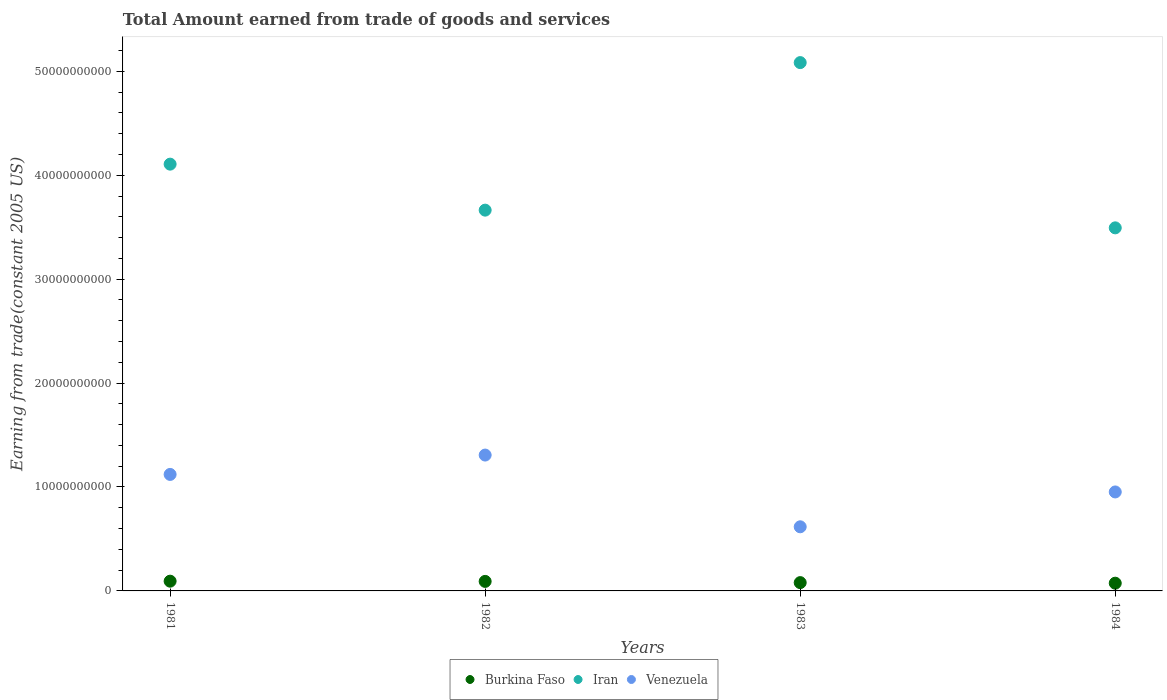Is the number of dotlines equal to the number of legend labels?
Offer a very short reply. Yes. What is the total amount earned by trading goods and services in Iran in 1983?
Give a very brief answer. 5.08e+1. Across all years, what is the maximum total amount earned by trading goods and services in Burkina Faso?
Offer a very short reply. 9.37e+08. Across all years, what is the minimum total amount earned by trading goods and services in Iran?
Provide a succinct answer. 3.49e+1. In which year was the total amount earned by trading goods and services in Iran maximum?
Make the answer very short. 1983. In which year was the total amount earned by trading goods and services in Iran minimum?
Keep it short and to the point. 1984. What is the total total amount earned by trading goods and services in Burkina Faso in the graph?
Provide a succinct answer. 3.40e+09. What is the difference between the total amount earned by trading goods and services in Venezuela in 1981 and that in 1984?
Your response must be concise. 1.69e+09. What is the difference between the total amount earned by trading goods and services in Venezuela in 1981 and the total amount earned by trading goods and services in Burkina Faso in 1982?
Ensure brevity in your answer.  1.03e+1. What is the average total amount earned by trading goods and services in Burkina Faso per year?
Offer a very short reply. 8.49e+08. In the year 1982, what is the difference between the total amount earned by trading goods and services in Venezuela and total amount earned by trading goods and services in Iran?
Provide a succinct answer. -2.36e+1. In how many years, is the total amount earned by trading goods and services in Iran greater than 20000000000 US$?
Keep it short and to the point. 4. What is the ratio of the total amount earned by trading goods and services in Iran in 1981 to that in 1984?
Keep it short and to the point. 1.18. Is the total amount earned by trading goods and services in Burkina Faso in 1981 less than that in 1983?
Make the answer very short. No. Is the difference between the total amount earned by trading goods and services in Venezuela in 1981 and 1982 greater than the difference between the total amount earned by trading goods and services in Iran in 1981 and 1982?
Ensure brevity in your answer.  No. What is the difference between the highest and the second highest total amount earned by trading goods and services in Burkina Faso?
Keep it short and to the point. 2.11e+07. What is the difference between the highest and the lowest total amount earned by trading goods and services in Venezuela?
Give a very brief answer. 6.90e+09. In how many years, is the total amount earned by trading goods and services in Iran greater than the average total amount earned by trading goods and services in Iran taken over all years?
Keep it short and to the point. 2. Is the sum of the total amount earned by trading goods and services in Burkina Faso in 1982 and 1984 greater than the maximum total amount earned by trading goods and services in Iran across all years?
Provide a succinct answer. No. Does the total amount earned by trading goods and services in Burkina Faso monotonically increase over the years?
Give a very brief answer. No. How many years are there in the graph?
Provide a succinct answer. 4. Are the values on the major ticks of Y-axis written in scientific E-notation?
Offer a terse response. No. Does the graph contain any zero values?
Provide a succinct answer. No. Where does the legend appear in the graph?
Provide a short and direct response. Bottom center. How many legend labels are there?
Your response must be concise. 3. How are the legend labels stacked?
Give a very brief answer. Horizontal. What is the title of the graph?
Provide a succinct answer. Total Amount earned from trade of goods and services. Does "India" appear as one of the legend labels in the graph?
Keep it short and to the point. No. What is the label or title of the Y-axis?
Your answer should be very brief. Earning from trade(constant 2005 US). What is the Earning from trade(constant 2005 US) in Burkina Faso in 1981?
Your answer should be compact. 9.37e+08. What is the Earning from trade(constant 2005 US) in Iran in 1981?
Provide a succinct answer. 4.11e+1. What is the Earning from trade(constant 2005 US) of Venezuela in 1981?
Keep it short and to the point. 1.12e+1. What is the Earning from trade(constant 2005 US) in Burkina Faso in 1982?
Keep it short and to the point. 9.16e+08. What is the Earning from trade(constant 2005 US) in Iran in 1982?
Provide a short and direct response. 3.66e+1. What is the Earning from trade(constant 2005 US) of Venezuela in 1982?
Provide a short and direct response. 1.31e+1. What is the Earning from trade(constant 2005 US) of Burkina Faso in 1983?
Your response must be concise. 7.99e+08. What is the Earning from trade(constant 2005 US) in Iran in 1983?
Provide a succinct answer. 5.08e+1. What is the Earning from trade(constant 2005 US) in Venezuela in 1983?
Offer a terse response. 6.17e+09. What is the Earning from trade(constant 2005 US) of Burkina Faso in 1984?
Your answer should be very brief. 7.44e+08. What is the Earning from trade(constant 2005 US) of Iran in 1984?
Ensure brevity in your answer.  3.49e+1. What is the Earning from trade(constant 2005 US) of Venezuela in 1984?
Offer a very short reply. 9.52e+09. Across all years, what is the maximum Earning from trade(constant 2005 US) in Burkina Faso?
Keep it short and to the point. 9.37e+08. Across all years, what is the maximum Earning from trade(constant 2005 US) of Iran?
Your answer should be very brief. 5.08e+1. Across all years, what is the maximum Earning from trade(constant 2005 US) of Venezuela?
Keep it short and to the point. 1.31e+1. Across all years, what is the minimum Earning from trade(constant 2005 US) in Burkina Faso?
Your answer should be compact. 7.44e+08. Across all years, what is the minimum Earning from trade(constant 2005 US) of Iran?
Offer a very short reply. 3.49e+1. Across all years, what is the minimum Earning from trade(constant 2005 US) in Venezuela?
Your answer should be very brief. 6.17e+09. What is the total Earning from trade(constant 2005 US) in Burkina Faso in the graph?
Your answer should be compact. 3.40e+09. What is the total Earning from trade(constant 2005 US) in Iran in the graph?
Your answer should be compact. 1.63e+11. What is the total Earning from trade(constant 2005 US) in Venezuela in the graph?
Keep it short and to the point. 4.00e+1. What is the difference between the Earning from trade(constant 2005 US) in Burkina Faso in 1981 and that in 1982?
Offer a very short reply. 2.11e+07. What is the difference between the Earning from trade(constant 2005 US) of Iran in 1981 and that in 1982?
Your answer should be compact. 4.43e+09. What is the difference between the Earning from trade(constant 2005 US) of Venezuela in 1981 and that in 1982?
Your answer should be compact. -1.86e+09. What is the difference between the Earning from trade(constant 2005 US) of Burkina Faso in 1981 and that in 1983?
Give a very brief answer. 1.39e+08. What is the difference between the Earning from trade(constant 2005 US) of Iran in 1981 and that in 1983?
Offer a very short reply. -9.77e+09. What is the difference between the Earning from trade(constant 2005 US) in Venezuela in 1981 and that in 1983?
Provide a succinct answer. 5.04e+09. What is the difference between the Earning from trade(constant 2005 US) in Burkina Faso in 1981 and that in 1984?
Offer a terse response. 1.93e+08. What is the difference between the Earning from trade(constant 2005 US) in Iran in 1981 and that in 1984?
Offer a very short reply. 6.13e+09. What is the difference between the Earning from trade(constant 2005 US) of Venezuela in 1981 and that in 1984?
Your response must be concise. 1.69e+09. What is the difference between the Earning from trade(constant 2005 US) in Burkina Faso in 1982 and that in 1983?
Keep it short and to the point. 1.17e+08. What is the difference between the Earning from trade(constant 2005 US) in Iran in 1982 and that in 1983?
Make the answer very short. -1.42e+1. What is the difference between the Earning from trade(constant 2005 US) in Venezuela in 1982 and that in 1983?
Offer a terse response. 6.90e+09. What is the difference between the Earning from trade(constant 2005 US) of Burkina Faso in 1982 and that in 1984?
Your answer should be compact. 1.72e+08. What is the difference between the Earning from trade(constant 2005 US) in Iran in 1982 and that in 1984?
Provide a short and direct response. 1.70e+09. What is the difference between the Earning from trade(constant 2005 US) in Venezuela in 1982 and that in 1984?
Your answer should be compact. 3.55e+09. What is the difference between the Earning from trade(constant 2005 US) in Burkina Faso in 1983 and that in 1984?
Keep it short and to the point. 5.48e+07. What is the difference between the Earning from trade(constant 2005 US) in Iran in 1983 and that in 1984?
Offer a terse response. 1.59e+1. What is the difference between the Earning from trade(constant 2005 US) in Venezuela in 1983 and that in 1984?
Provide a succinct answer. -3.35e+09. What is the difference between the Earning from trade(constant 2005 US) in Burkina Faso in 1981 and the Earning from trade(constant 2005 US) in Iran in 1982?
Provide a short and direct response. -3.57e+1. What is the difference between the Earning from trade(constant 2005 US) in Burkina Faso in 1981 and the Earning from trade(constant 2005 US) in Venezuela in 1982?
Make the answer very short. -1.21e+1. What is the difference between the Earning from trade(constant 2005 US) in Iran in 1981 and the Earning from trade(constant 2005 US) in Venezuela in 1982?
Your answer should be compact. 2.80e+1. What is the difference between the Earning from trade(constant 2005 US) of Burkina Faso in 1981 and the Earning from trade(constant 2005 US) of Iran in 1983?
Your response must be concise. -4.99e+1. What is the difference between the Earning from trade(constant 2005 US) of Burkina Faso in 1981 and the Earning from trade(constant 2005 US) of Venezuela in 1983?
Your response must be concise. -5.23e+09. What is the difference between the Earning from trade(constant 2005 US) in Iran in 1981 and the Earning from trade(constant 2005 US) in Venezuela in 1983?
Provide a succinct answer. 3.49e+1. What is the difference between the Earning from trade(constant 2005 US) of Burkina Faso in 1981 and the Earning from trade(constant 2005 US) of Iran in 1984?
Keep it short and to the point. -3.40e+1. What is the difference between the Earning from trade(constant 2005 US) in Burkina Faso in 1981 and the Earning from trade(constant 2005 US) in Venezuela in 1984?
Ensure brevity in your answer.  -8.59e+09. What is the difference between the Earning from trade(constant 2005 US) in Iran in 1981 and the Earning from trade(constant 2005 US) in Venezuela in 1984?
Offer a very short reply. 3.15e+1. What is the difference between the Earning from trade(constant 2005 US) in Burkina Faso in 1982 and the Earning from trade(constant 2005 US) in Iran in 1983?
Make the answer very short. -4.99e+1. What is the difference between the Earning from trade(constant 2005 US) of Burkina Faso in 1982 and the Earning from trade(constant 2005 US) of Venezuela in 1983?
Give a very brief answer. -5.25e+09. What is the difference between the Earning from trade(constant 2005 US) of Iran in 1982 and the Earning from trade(constant 2005 US) of Venezuela in 1983?
Keep it short and to the point. 3.05e+1. What is the difference between the Earning from trade(constant 2005 US) of Burkina Faso in 1982 and the Earning from trade(constant 2005 US) of Iran in 1984?
Give a very brief answer. -3.40e+1. What is the difference between the Earning from trade(constant 2005 US) of Burkina Faso in 1982 and the Earning from trade(constant 2005 US) of Venezuela in 1984?
Make the answer very short. -8.61e+09. What is the difference between the Earning from trade(constant 2005 US) in Iran in 1982 and the Earning from trade(constant 2005 US) in Venezuela in 1984?
Your response must be concise. 2.71e+1. What is the difference between the Earning from trade(constant 2005 US) in Burkina Faso in 1983 and the Earning from trade(constant 2005 US) in Iran in 1984?
Keep it short and to the point. -3.41e+1. What is the difference between the Earning from trade(constant 2005 US) of Burkina Faso in 1983 and the Earning from trade(constant 2005 US) of Venezuela in 1984?
Provide a short and direct response. -8.72e+09. What is the difference between the Earning from trade(constant 2005 US) in Iran in 1983 and the Earning from trade(constant 2005 US) in Venezuela in 1984?
Offer a terse response. 4.13e+1. What is the average Earning from trade(constant 2005 US) of Burkina Faso per year?
Provide a succinct answer. 8.49e+08. What is the average Earning from trade(constant 2005 US) of Iran per year?
Offer a terse response. 4.09e+1. What is the average Earning from trade(constant 2005 US) of Venezuela per year?
Offer a terse response. 9.99e+09. In the year 1981, what is the difference between the Earning from trade(constant 2005 US) of Burkina Faso and Earning from trade(constant 2005 US) of Iran?
Make the answer very short. -4.01e+1. In the year 1981, what is the difference between the Earning from trade(constant 2005 US) in Burkina Faso and Earning from trade(constant 2005 US) in Venezuela?
Provide a short and direct response. -1.03e+1. In the year 1981, what is the difference between the Earning from trade(constant 2005 US) of Iran and Earning from trade(constant 2005 US) of Venezuela?
Offer a very short reply. 2.99e+1. In the year 1982, what is the difference between the Earning from trade(constant 2005 US) in Burkina Faso and Earning from trade(constant 2005 US) in Iran?
Offer a very short reply. -3.57e+1. In the year 1982, what is the difference between the Earning from trade(constant 2005 US) in Burkina Faso and Earning from trade(constant 2005 US) in Venezuela?
Your answer should be compact. -1.22e+1. In the year 1982, what is the difference between the Earning from trade(constant 2005 US) in Iran and Earning from trade(constant 2005 US) in Venezuela?
Ensure brevity in your answer.  2.36e+1. In the year 1983, what is the difference between the Earning from trade(constant 2005 US) in Burkina Faso and Earning from trade(constant 2005 US) in Iran?
Provide a short and direct response. -5.00e+1. In the year 1983, what is the difference between the Earning from trade(constant 2005 US) in Burkina Faso and Earning from trade(constant 2005 US) in Venezuela?
Provide a short and direct response. -5.37e+09. In the year 1983, what is the difference between the Earning from trade(constant 2005 US) in Iran and Earning from trade(constant 2005 US) in Venezuela?
Make the answer very short. 4.47e+1. In the year 1984, what is the difference between the Earning from trade(constant 2005 US) in Burkina Faso and Earning from trade(constant 2005 US) in Iran?
Offer a terse response. -3.42e+1. In the year 1984, what is the difference between the Earning from trade(constant 2005 US) of Burkina Faso and Earning from trade(constant 2005 US) of Venezuela?
Ensure brevity in your answer.  -8.78e+09. In the year 1984, what is the difference between the Earning from trade(constant 2005 US) in Iran and Earning from trade(constant 2005 US) in Venezuela?
Offer a terse response. 2.54e+1. What is the ratio of the Earning from trade(constant 2005 US) in Burkina Faso in 1981 to that in 1982?
Give a very brief answer. 1.02. What is the ratio of the Earning from trade(constant 2005 US) of Iran in 1981 to that in 1982?
Your response must be concise. 1.12. What is the ratio of the Earning from trade(constant 2005 US) in Venezuela in 1981 to that in 1982?
Provide a succinct answer. 0.86. What is the ratio of the Earning from trade(constant 2005 US) of Burkina Faso in 1981 to that in 1983?
Your answer should be compact. 1.17. What is the ratio of the Earning from trade(constant 2005 US) in Iran in 1981 to that in 1983?
Give a very brief answer. 0.81. What is the ratio of the Earning from trade(constant 2005 US) of Venezuela in 1981 to that in 1983?
Your answer should be compact. 1.82. What is the ratio of the Earning from trade(constant 2005 US) in Burkina Faso in 1981 to that in 1984?
Keep it short and to the point. 1.26. What is the ratio of the Earning from trade(constant 2005 US) in Iran in 1981 to that in 1984?
Ensure brevity in your answer.  1.18. What is the ratio of the Earning from trade(constant 2005 US) of Venezuela in 1981 to that in 1984?
Ensure brevity in your answer.  1.18. What is the ratio of the Earning from trade(constant 2005 US) of Burkina Faso in 1982 to that in 1983?
Provide a short and direct response. 1.15. What is the ratio of the Earning from trade(constant 2005 US) of Iran in 1982 to that in 1983?
Provide a succinct answer. 0.72. What is the ratio of the Earning from trade(constant 2005 US) in Venezuela in 1982 to that in 1983?
Ensure brevity in your answer.  2.12. What is the ratio of the Earning from trade(constant 2005 US) in Burkina Faso in 1982 to that in 1984?
Ensure brevity in your answer.  1.23. What is the ratio of the Earning from trade(constant 2005 US) of Iran in 1982 to that in 1984?
Provide a succinct answer. 1.05. What is the ratio of the Earning from trade(constant 2005 US) in Venezuela in 1982 to that in 1984?
Give a very brief answer. 1.37. What is the ratio of the Earning from trade(constant 2005 US) of Burkina Faso in 1983 to that in 1984?
Offer a very short reply. 1.07. What is the ratio of the Earning from trade(constant 2005 US) of Iran in 1983 to that in 1984?
Your answer should be compact. 1.46. What is the ratio of the Earning from trade(constant 2005 US) of Venezuela in 1983 to that in 1984?
Provide a succinct answer. 0.65. What is the difference between the highest and the second highest Earning from trade(constant 2005 US) in Burkina Faso?
Your answer should be compact. 2.11e+07. What is the difference between the highest and the second highest Earning from trade(constant 2005 US) of Iran?
Provide a short and direct response. 9.77e+09. What is the difference between the highest and the second highest Earning from trade(constant 2005 US) in Venezuela?
Provide a succinct answer. 1.86e+09. What is the difference between the highest and the lowest Earning from trade(constant 2005 US) of Burkina Faso?
Provide a succinct answer. 1.93e+08. What is the difference between the highest and the lowest Earning from trade(constant 2005 US) in Iran?
Make the answer very short. 1.59e+1. What is the difference between the highest and the lowest Earning from trade(constant 2005 US) of Venezuela?
Offer a very short reply. 6.90e+09. 